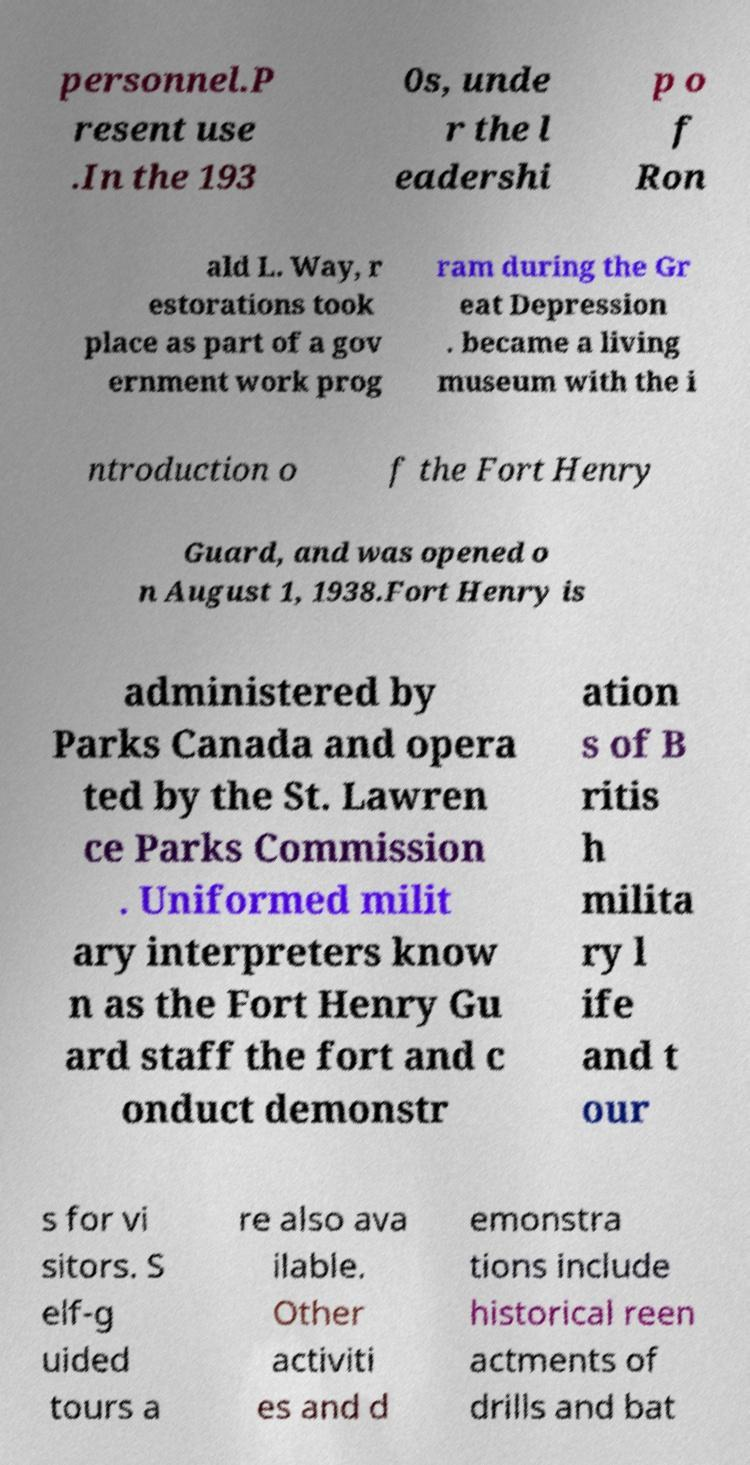What messages or text are displayed in this image? I need them in a readable, typed format. personnel.P resent use .In the 193 0s, unde r the l eadershi p o f Ron ald L. Way, r estorations took place as part of a gov ernment work prog ram during the Gr eat Depression . became a living museum with the i ntroduction o f the Fort Henry Guard, and was opened o n August 1, 1938.Fort Henry is administered by Parks Canada and opera ted by the St. Lawren ce Parks Commission . Uniformed milit ary interpreters know n as the Fort Henry Gu ard staff the fort and c onduct demonstr ation s of B ritis h milita ry l ife and t our s for vi sitors. S elf-g uided tours a re also ava ilable. Other activiti es and d emonstra tions include historical reen actments of drills and bat 